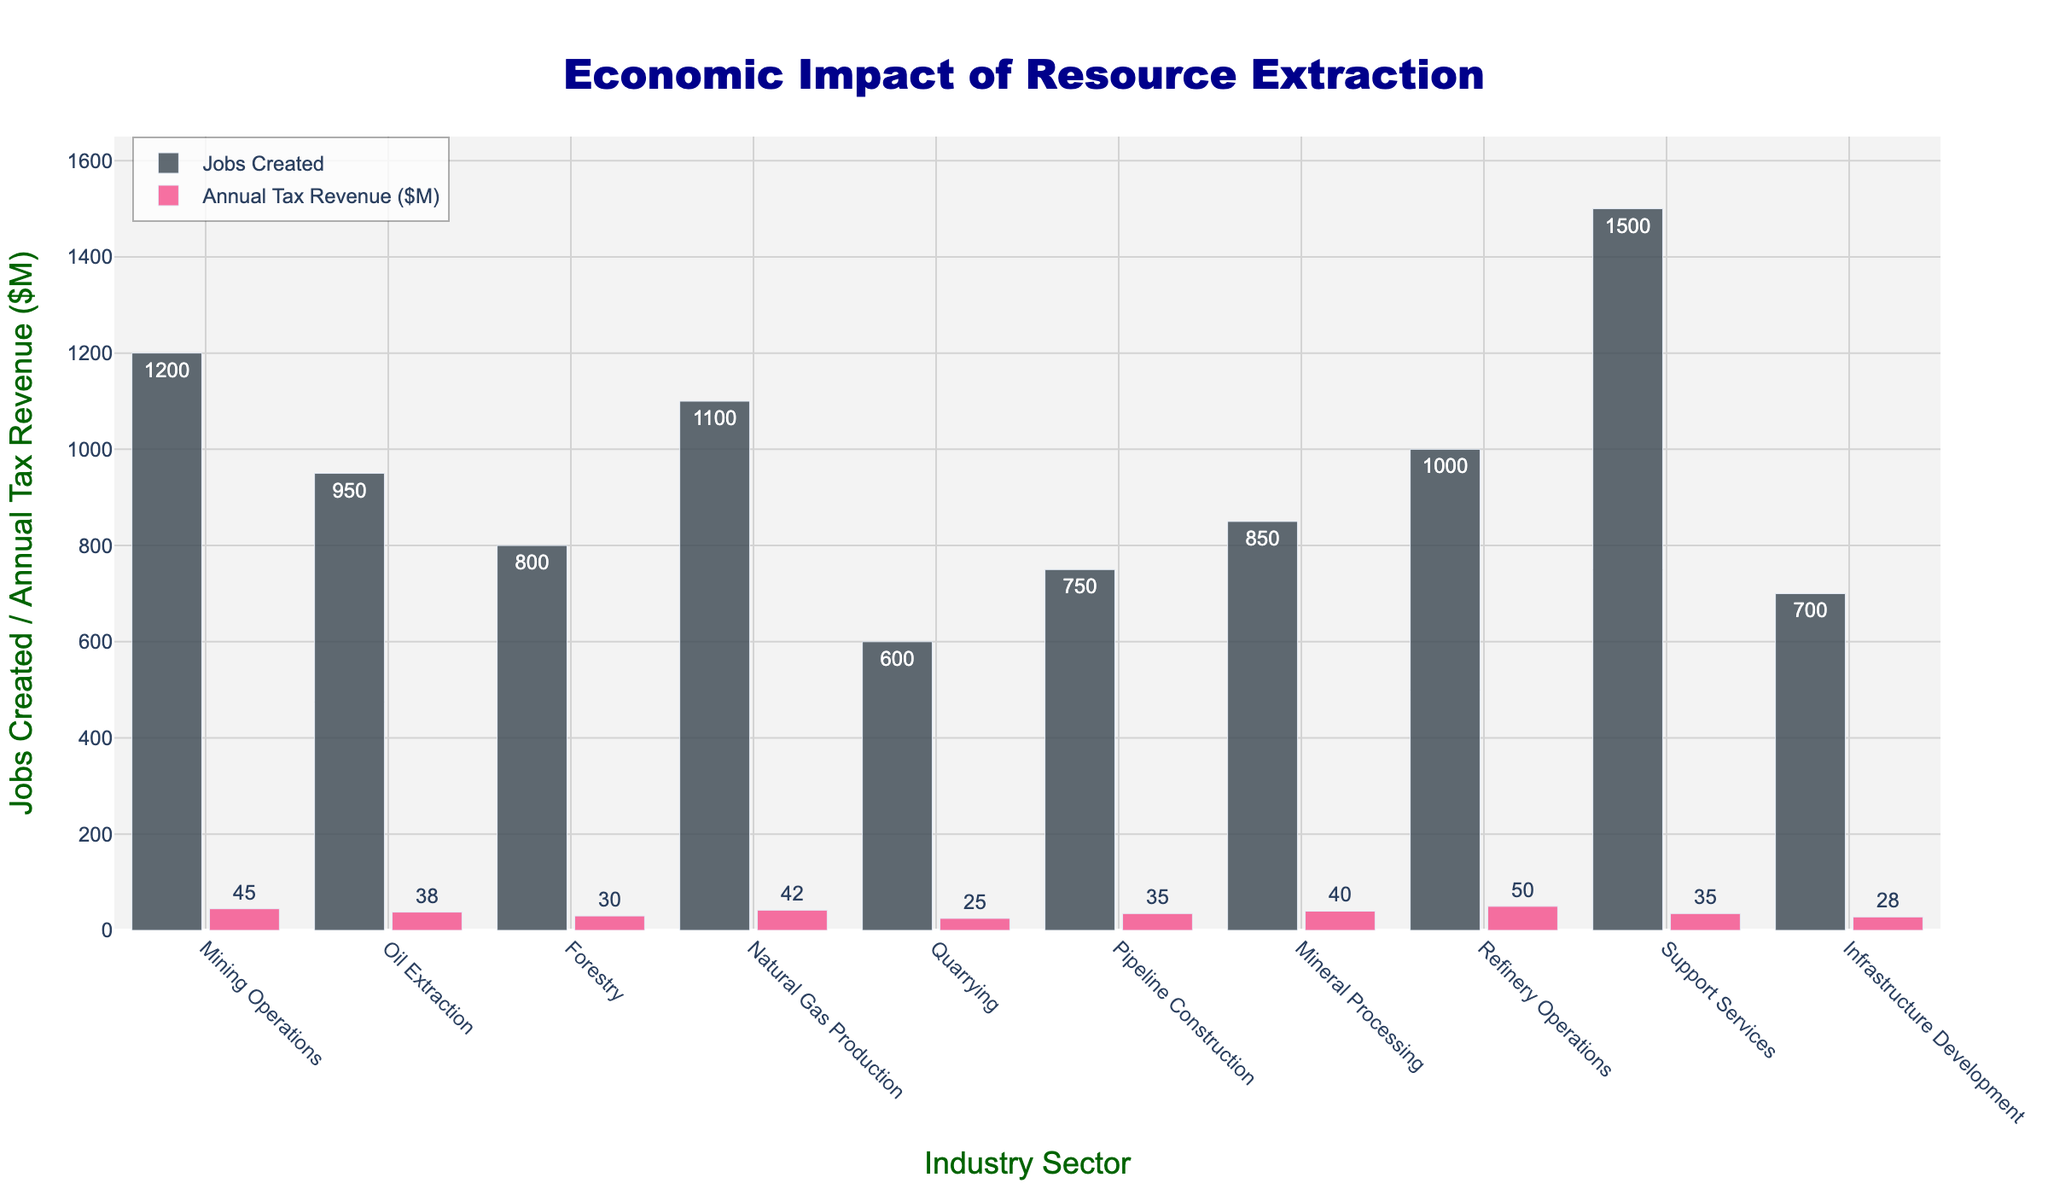Which industry sector creates the most jobs? By examining the height of the bars associated with "Jobs Created" for each sector, we see that Support Services creates the most jobs with a value of 1500.
Answer: Support Services Which sector contributes the highest annual tax revenue? Observing the height of the bars for "Annual Tax Revenue ($M)," Refinery Operations has the tallest bar at $50M.
Answer: Refinery Operations How many fewer jobs does Quarrying create compared to Mining Operations? Mining Operations creates 1200 jobs, and Quarrying creates 600 jobs. The difference is 1200 - 600 = 600.
Answer: 600 Compare the average number of jobs created across Natural Gas Production, Oil Extraction, and Forestry. The average is calculated by summing the jobs created in these sectors (1100 + 950 + 800 = 2850) and dividing by 3. So, the average is 2850 / 3 = 950.
Answer: 950 Which sector shows a balance between job creation and significant tax revenue? Support Services creates the most jobs (1500) and also contributes a considerable amount ($35M) in tax revenue, showing a balance between the two metrics.
Answer: Support Services Compare the job creation in Refinery Operations and Support Services. Refinery Operations creates 1000 jobs, while Support Services creates 1500 jobs. Therefore, Support Services creates 500 more jobs.
Answer: Support Services Which data point is the smallest in job creation? Observing the "Jobs Created" bars, Quarrying has the smallest value with 600 jobs created.
Answer: Quarrying Compare the annual tax revenue contribution between Pipeline Construction and Mineral Processing. Pipeline Construction contributes $35M and Mineral Processing contributes $40M in annual tax revenue, so Mineral Processing contributes $5M more.
Answer: Mineral Processing To which sector does the lowest job creation belong and what is its annual tax revenue? Quarrying has the lowest job creation (600 jobs) and its annual tax revenue is $25M.
Answer: Quarrying, $25M 